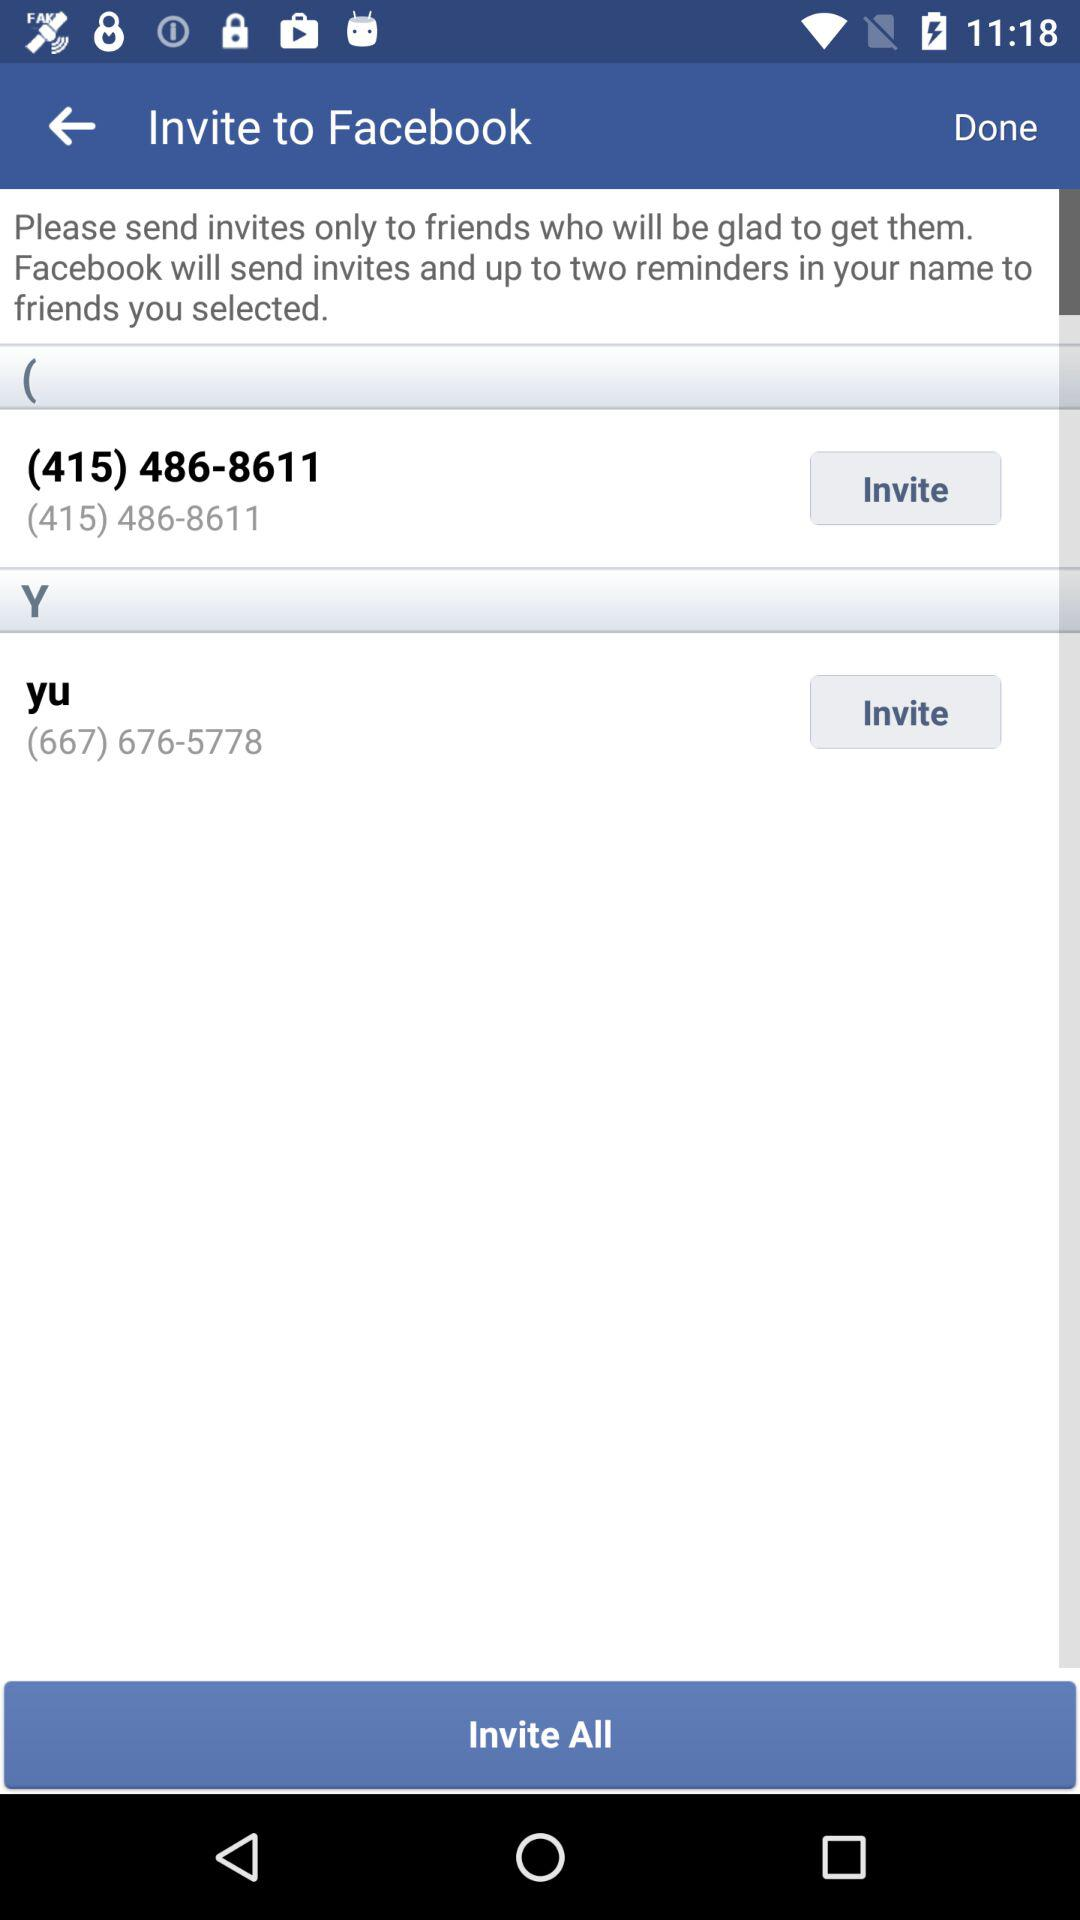How many friends have you selected to invite?
Answer the question using a single word or phrase. 2 